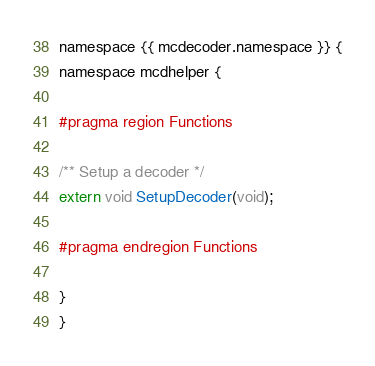Convert code to text. <code><loc_0><loc_0><loc_500><loc_500><_C_>namespace {{ mcdecoder.namespace }} {
namespace mcdhelper {

#pragma region Functions

/** Setup a decoder */
extern void SetupDecoder(void);

#pragma endregion Functions

}
}
</code> 